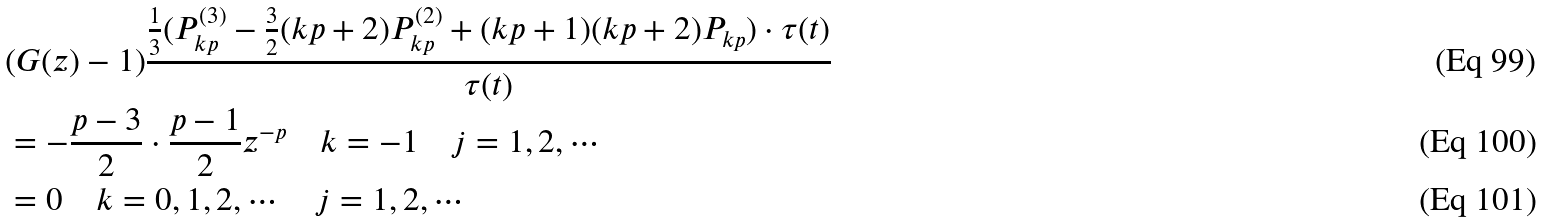<formula> <loc_0><loc_0><loc_500><loc_500>& ( G ( z ) - 1 ) \frac { \frac { 1 } { 3 } ( P _ { k p } ^ { ( 3 ) } - \frac { 3 } { 2 } ( k p + 2 ) P _ { k p } ^ { ( 2 ) } + ( k p + 1 ) ( k p + 2 ) P _ { k p } ) \cdot \tau ( t ) } { \tau ( t ) } \\ & = - \frac { p - 3 } { 2 } \cdot \frac { p - 1 } { 2 } z ^ { - p } \quad k = - 1 \quad j = 1 , 2 , \cdots \\ & = 0 \quad k = 0 , 1 , 2 , \cdots \quad j = 1 , 2 , \cdots</formula> 